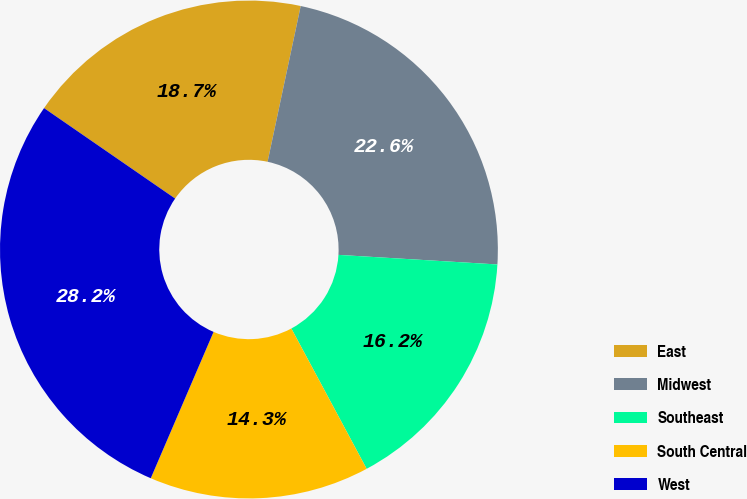Convert chart. <chart><loc_0><loc_0><loc_500><loc_500><pie_chart><fcel>East<fcel>Midwest<fcel>Southeast<fcel>South Central<fcel>West<nl><fcel>18.72%<fcel>22.62%<fcel>16.2%<fcel>14.29%<fcel>28.16%<nl></chart> 